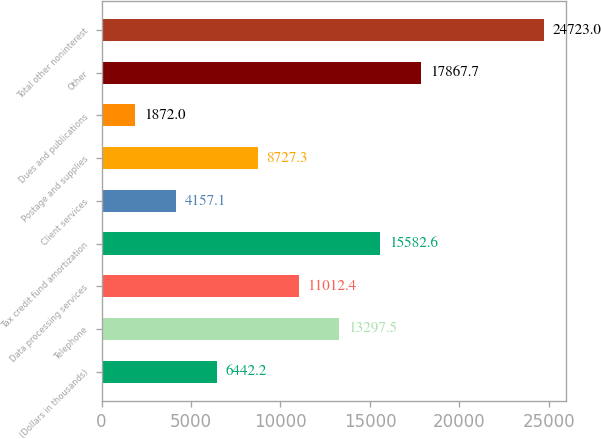Convert chart to OTSL. <chart><loc_0><loc_0><loc_500><loc_500><bar_chart><fcel>(Dollars in thousands)<fcel>Telephone<fcel>Data processing services<fcel>Tax credit fund amortization<fcel>Client services<fcel>Postage and supplies<fcel>Dues and publications<fcel>Other<fcel>Total other noninterest<nl><fcel>6442.2<fcel>13297.5<fcel>11012.4<fcel>15582.6<fcel>4157.1<fcel>8727.3<fcel>1872<fcel>17867.7<fcel>24723<nl></chart> 